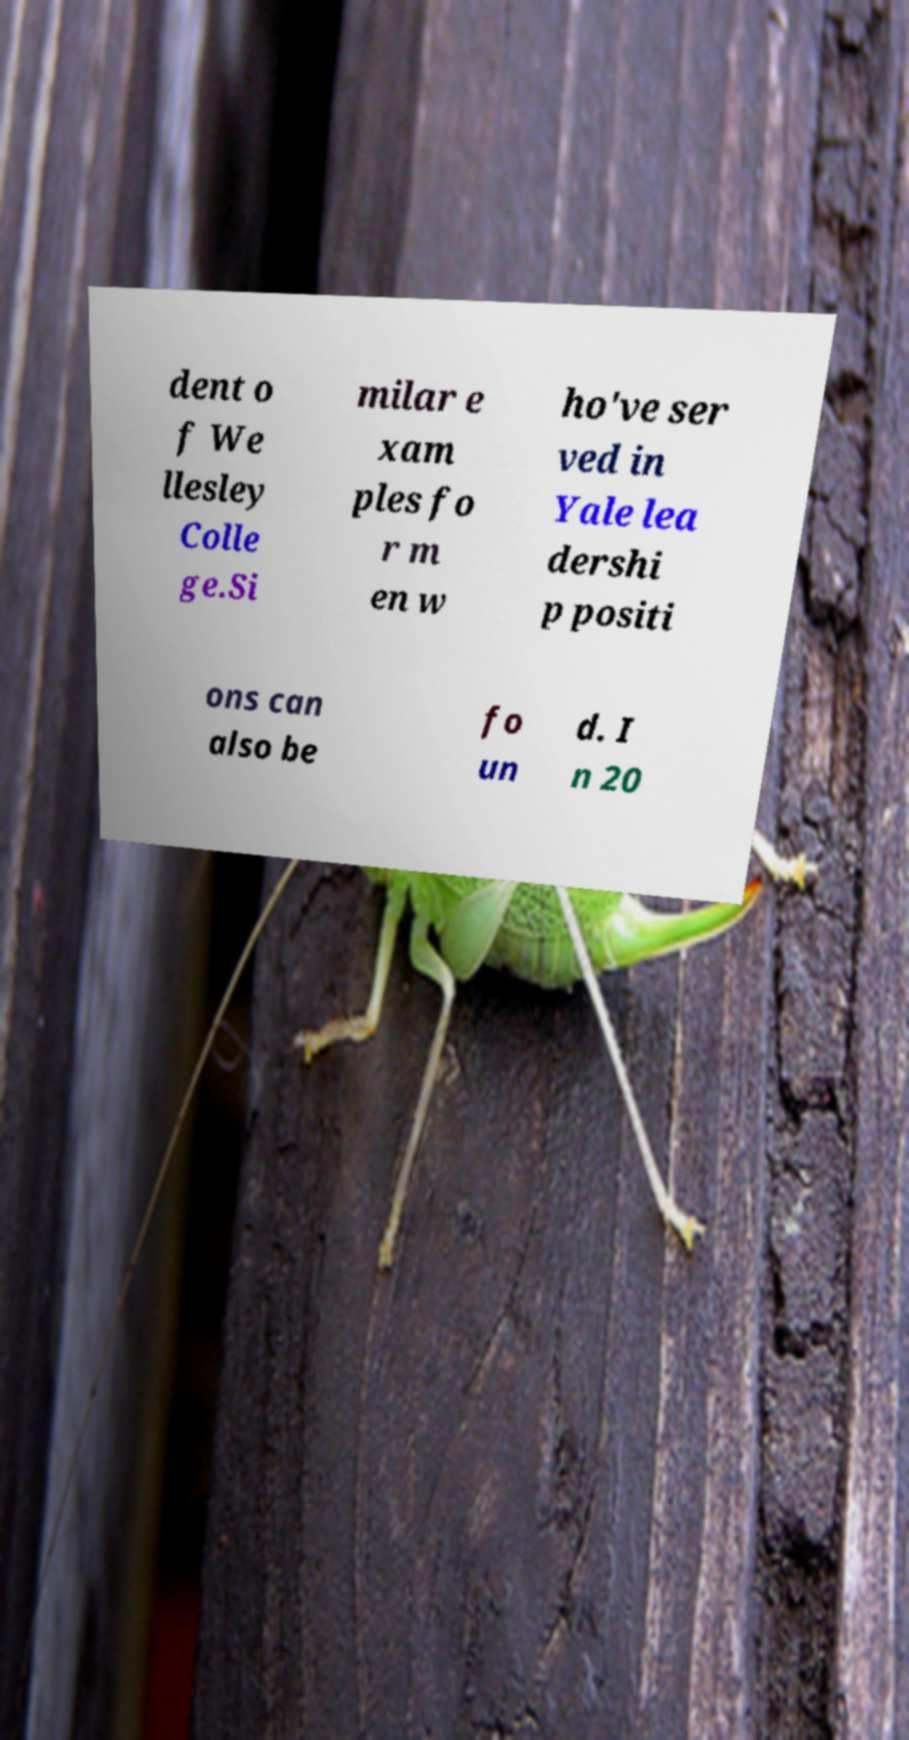For documentation purposes, I need the text within this image transcribed. Could you provide that? dent o f We llesley Colle ge.Si milar e xam ples fo r m en w ho've ser ved in Yale lea dershi p positi ons can also be fo un d. I n 20 